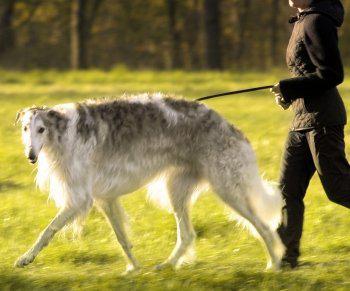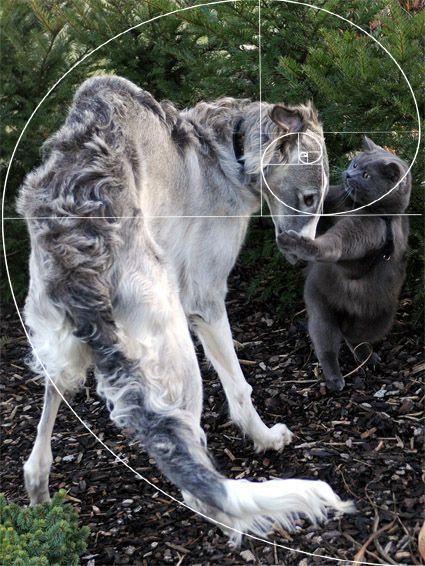The first image is the image on the left, the second image is the image on the right. Assess this claim about the two images: "There are two dogs in the left image.". Correct or not? Answer yes or no. No. The first image is the image on the left, the second image is the image on the right. Given the left and right images, does the statement "There are exactly four dogs in each set of images." hold true? Answer yes or no. No. 